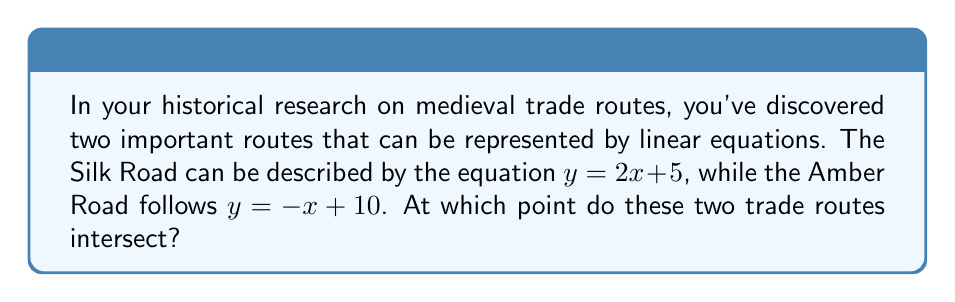Give your solution to this math problem. To find the intersection point of these two trade routes, we need to solve the system of equations:

$$
\begin{cases}
y = 2x + 5 \quad \text{(Silk Road)} \\
y = -x + 10 \quad \text{(Amber Road)}
\end{cases}
$$

Step 1: Since both equations are equal to $y$, we can set them equal to each other:
$2x + 5 = -x + 10$

Step 2: Solve for $x$ by adding $x$ to both sides and subtracting 5 from both sides:
$3x = 5$

Step 3: Divide both sides by 3 to isolate $x$:
$x = \frac{5}{3}$

Step 4: Substitute this $x$ value into either of the original equations. Let's use the Silk Road equation:
$y = 2(\frac{5}{3}) + 5$

Step 5: Simplify:
$y = \frac{10}{3} + 5 = \frac{10}{3} + \frac{15}{3} = \frac{25}{3}$

Therefore, the intersection point is $(\frac{5}{3}, \frac{25}{3})$.
Answer: $(\frac{5}{3}, \frac{25}{3})$ 